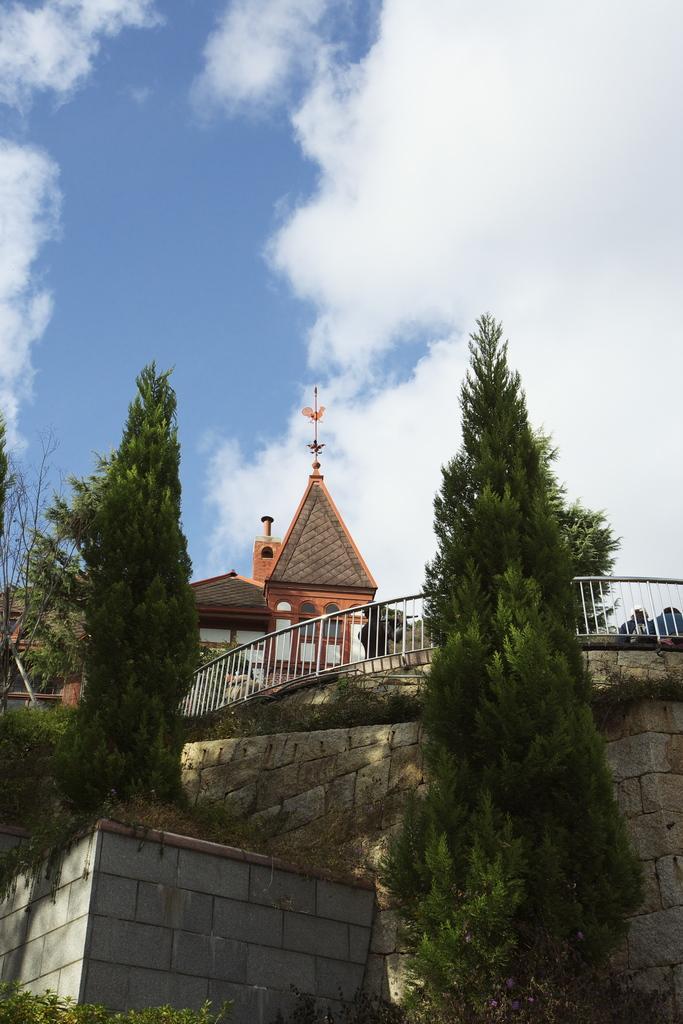Could you give a brief overview of what you see in this image? In this image in the center there are some houses and in the foreground there are some trees, wall and a fence. At the top of the image there is sky. 